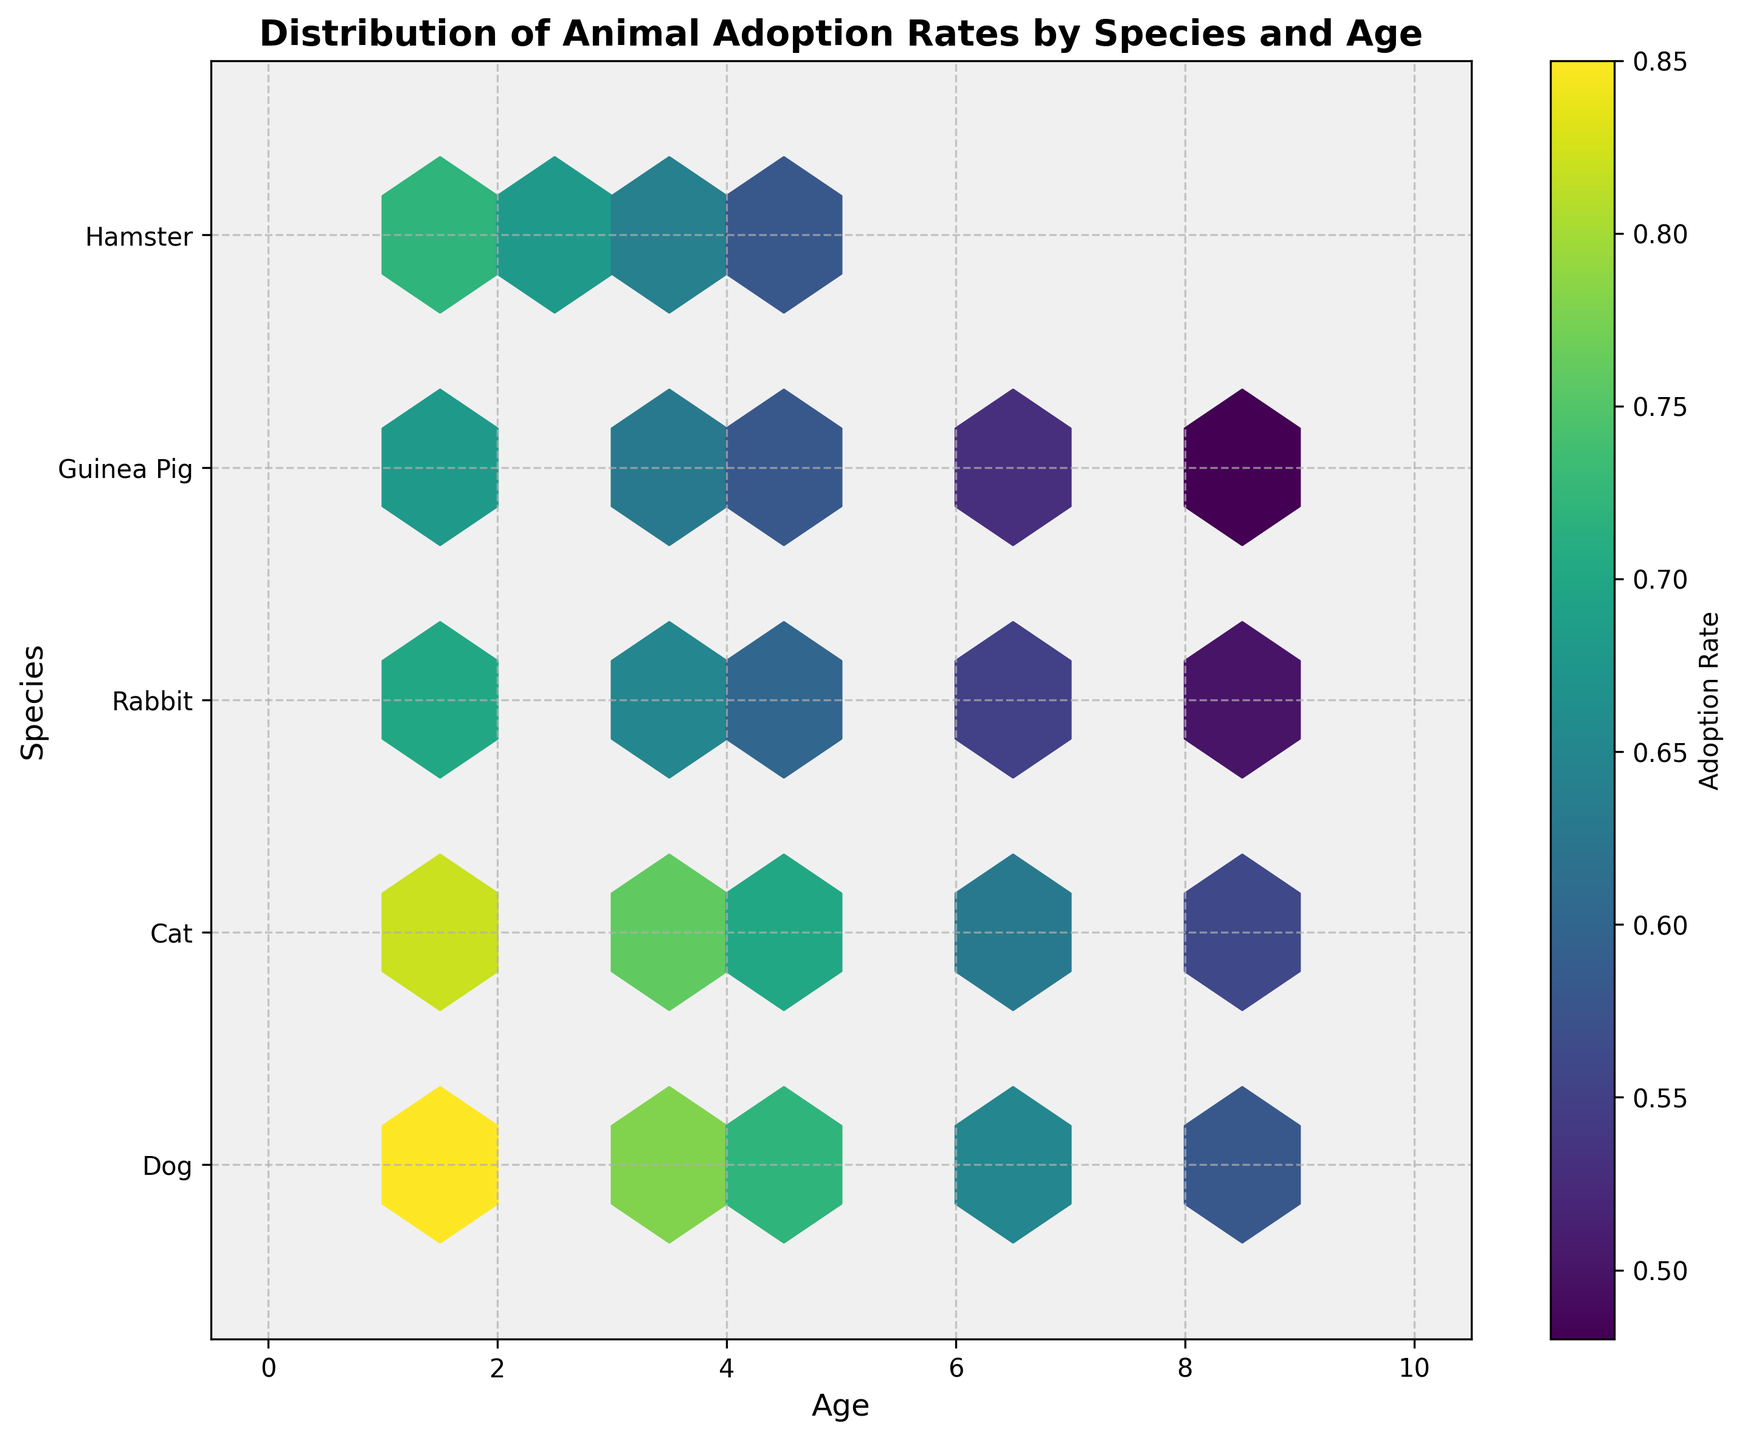what is the title of the plot? The title of the plot is displayed at the top and indicates the main topic of the plot. It reads as 'Distribution of Animal Adoption Rates by Species and Age'.
Answer: Distribution of Animal Adoption Rates by Species and Age what do the x and y axes represent? The labels on the x and y axes specify what each axis represents. The x-axis represents 'Age' of the animals, while the y-axis represents 'Species'.
Answer: Age and Species which species is represented by the highest numeric value on the y-axis? By looking at the y-axis and checking the species labels, we can see that the highest numeric value corresponds to the species 'Hamster'.
Answer: Hamster what does the color scale represent? The color scale shown by the color bar on the right side of the plot indicates 'Adoption Rate'. Colors change from low to high indicating different adoption rates.
Answer: Adoption Rate are younger animals generally adopted at a higher rate? By observing the colors on the left side of the plot (young age) and comparing them to the colors on the right side (older age), we see that younger animals tend to have higher adoption rates (brighter colors) than older animals.
Answer: Yes which species generally has the highest adoption rate for 1-year olds? Looking at the hexagons along the Age=1 line and comparing the colors, the species with the brightest color (highest adoption rate) is 'Dog'.
Answer: Dog how does the adoption rate for cats change as they age? Observing the color of the hexagons along the 'Cat' row, which corresponds to Age=1 to Age=9, we see that the color darkens, indicating a decrease in the adoption rate.
Answer: Decreases which species has the least variation in adoption rates across different ages? By comparing the range of colors for each species, 'Guinea Pig' shows the least variation since the color changes are subtler compared to other species.
Answer: Guinea Pig at what age do rabbits have the highest adoption rate? By looking at the row for 'Rabbit' and identifying the brightest hexagon, rabbits have the highest adoption rate at Age=1.
Answer: Age=1 how do adoption rates of guinea pigs compare to those of cats at age 5? Observing the colors at the intersection of Age=5 for both species, we see that the color is slightly brighter for cats than for guinea pigs, indicating a higher adoption rate for cats.
Answer: Cats have a higher rate 